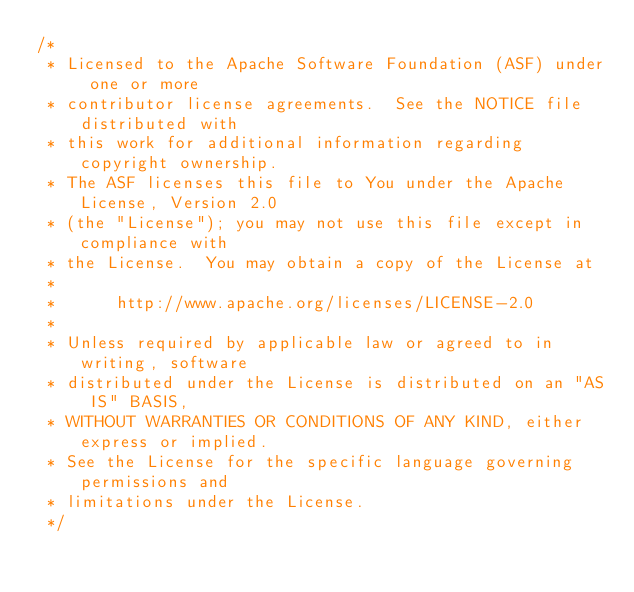<code> <loc_0><loc_0><loc_500><loc_500><_Java_>/*
 * Licensed to the Apache Software Foundation (ASF) under one or more
 * contributor license agreements.  See the NOTICE file distributed with
 * this work for additional information regarding copyright ownership.
 * The ASF licenses this file to You under the Apache License, Version 2.0
 * (the "License"); you may not use this file except in compliance with
 * the License.  You may obtain a copy of the License at
 *
 *      http://www.apache.org/licenses/LICENSE-2.0
 *
 * Unless required by applicable law or agreed to in writing, software
 * distributed under the License is distributed on an "AS IS" BASIS,
 * WITHOUT WARRANTIES OR CONDITIONS OF ANY KIND, either express or implied.
 * See the License for the specific language governing permissions and
 * limitations under the License.
 */</code> 